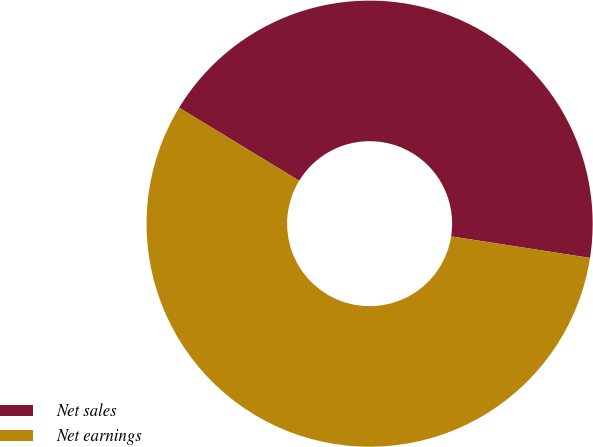Convert chart. <chart><loc_0><loc_0><loc_500><loc_500><pie_chart><fcel>Net sales<fcel>Net earnings<nl><fcel>43.75%<fcel>56.25%<nl></chart> 